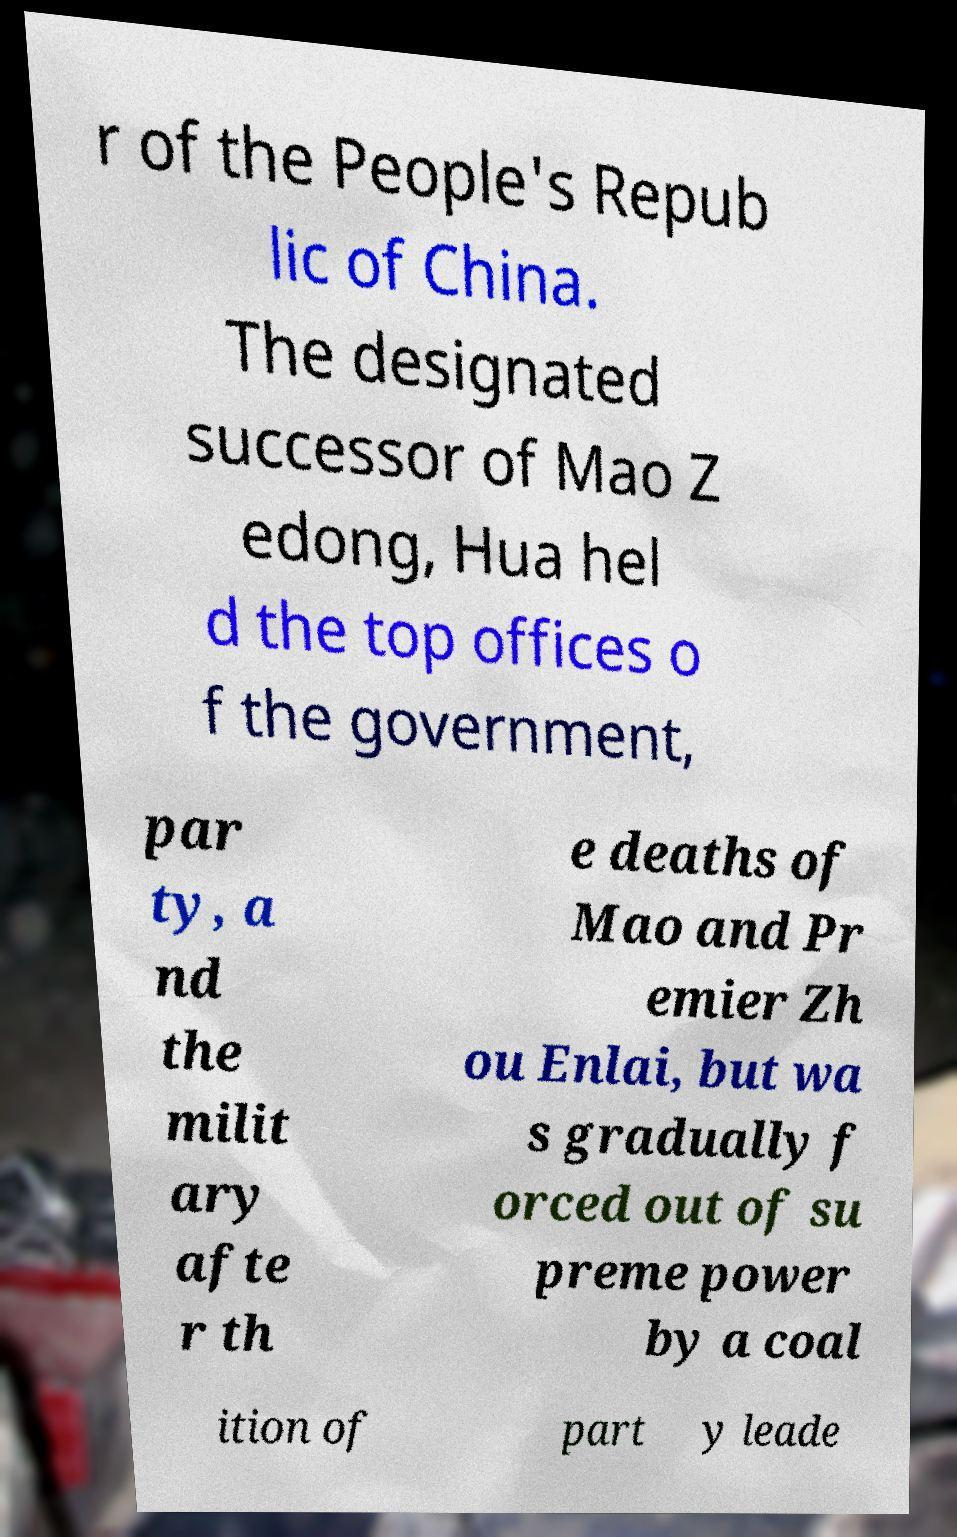Could you extract and type out the text from this image? r of the People's Repub lic of China. The designated successor of Mao Z edong, Hua hel d the top offices o f the government, par ty, a nd the milit ary afte r th e deaths of Mao and Pr emier Zh ou Enlai, but wa s gradually f orced out of su preme power by a coal ition of part y leade 